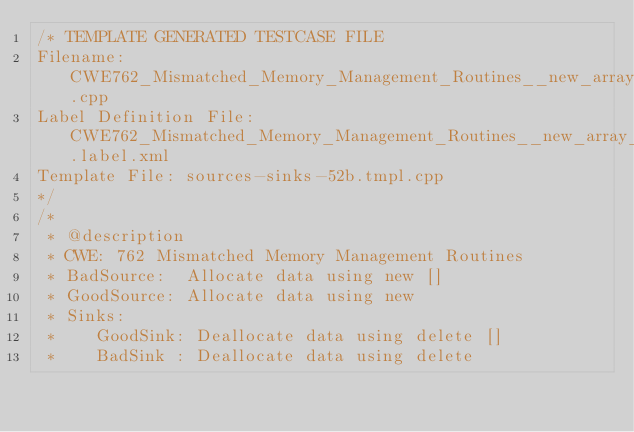<code> <loc_0><loc_0><loc_500><loc_500><_C++_>/* TEMPLATE GENERATED TESTCASE FILE
Filename: CWE762_Mismatched_Memory_Management_Routines__new_array_delete_class_52b.cpp
Label Definition File: CWE762_Mismatched_Memory_Management_Routines__new_array_delete.label.xml
Template File: sources-sinks-52b.tmpl.cpp
*/
/*
 * @description
 * CWE: 762 Mismatched Memory Management Routines
 * BadSource:  Allocate data using new []
 * GoodSource: Allocate data using new
 * Sinks:
 *    GoodSink: Deallocate data using delete []
 *    BadSink : Deallocate data using delete</code> 